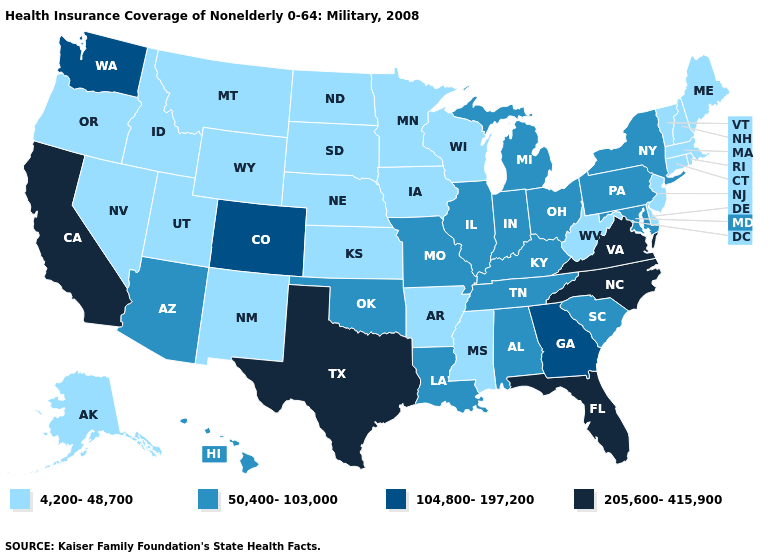Does Arkansas have the same value as South Carolina?
Answer briefly. No. Name the states that have a value in the range 205,600-415,900?
Write a very short answer. California, Florida, North Carolina, Texas, Virginia. Which states hav the highest value in the West?
Concise answer only. California. Name the states that have a value in the range 50,400-103,000?
Answer briefly. Alabama, Arizona, Hawaii, Illinois, Indiana, Kentucky, Louisiana, Maryland, Michigan, Missouri, New York, Ohio, Oklahoma, Pennsylvania, South Carolina, Tennessee. What is the highest value in the West ?
Give a very brief answer. 205,600-415,900. Name the states that have a value in the range 205,600-415,900?
Answer briefly. California, Florida, North Carolina, Texas, Virginia. Does the map have missing data?
Be succinct. No. Is the legend a continuous bar?
Be succinct. No. Among the states that border Wisconsin , does Illinois have the lowest value?
Give a very brief answer. No. What is the highest value in states that border Vermont?
Write a very short answer. 50,400-103,000. Which states hav the highest value in the South?
Short answer required. Florida, North Carolina, Texas, Virginia. Does Louisiana have the same value as Arizona?
Quick response, please. Yes. Does Wisconsin have the highest value in the MidWest?
Keep it brief. No. Does New York have the highest value in the Northeast?
Quick response, please. Yes. Does Wisconsin have a lower value than Rhode Island?
Give a very brief answer. No. 